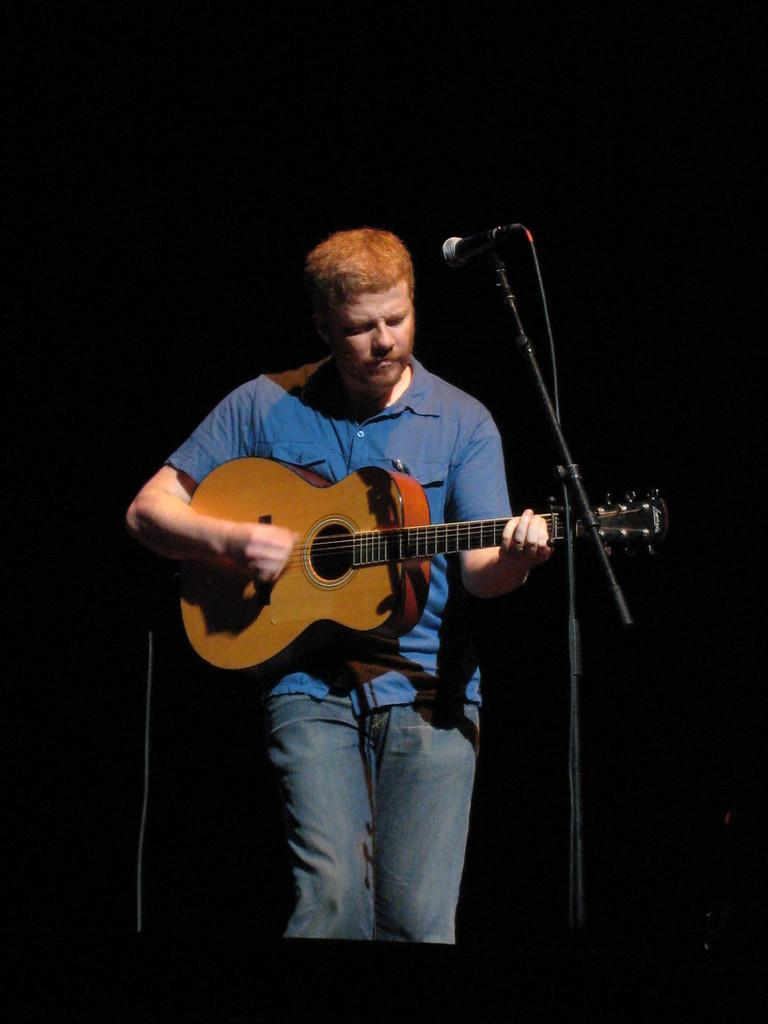What is the man in the image doing? The man is playing a guitar in the image. What object is present that might be used for amplifying the man's voice? There is a microphone in the image. What type of scent can be detected coming from the man's guitar in the image? There is no mention of a scent in the image, and the man's guitar does not emit any odor. 